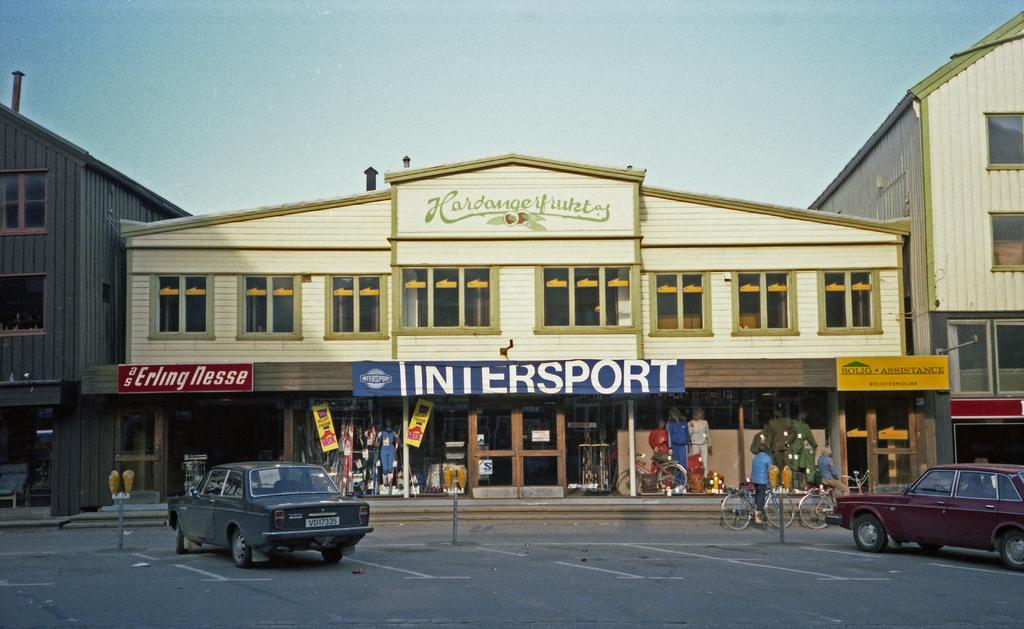Please provide a concise description of this image. At the center of the image there are buildings and stalls, in front of them there are few vehicles and bicycles are on the road. In the background there is a sky. 